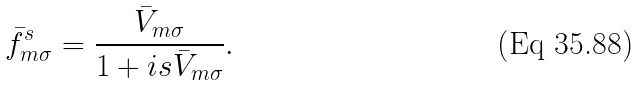<formula> <loc_0><loc_0><loc_500><loc_500>\bar { f } ^ { s } _ { m \sigma } = \frac { \bar { V } _ { m \sigma } } { 1 + i s \bar { V } _ { m \sigma } } .</formula> 